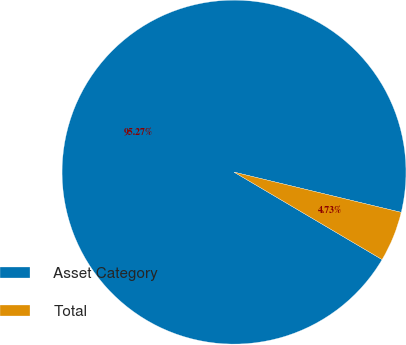Convert chart. <chart><loc_0><loc_0><loc_500><loc_500><pie_chart><fcel>Asset Category<fcel>Total<nl><fcel>95.27%<fcel>4.73%<nl></chart> 